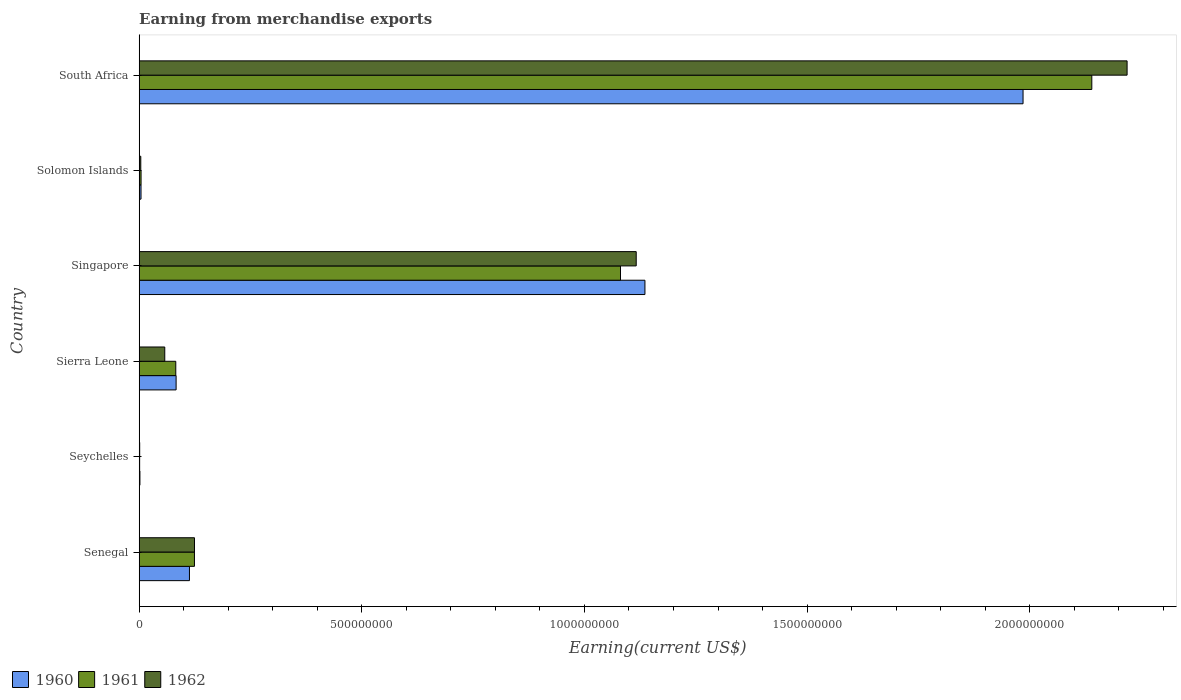How many different coloured bars are there?
Your answer should be compact. 3. How many bars are there on the 4th tick from the top?
Offer a very short reply. 3. How many bars are there on the 6th tick from the bottom?
Your answer should be compact. 3. What is the label of the 3rd group of bars from the top?
Ensure brevity in your answer.  Singapore. What is the amount earned from merchandise exports in 1960 in Sierra Leone?
Give a very brief answer. 8.30e+07. Across all countries, what is the maximum amount earned from merchandise exports in 1962?
Provide a succinct answer. 2.22e+09. Across all countries, what is the minimum amount earned from merchandise exports in 1961?
Provide a succinct answer. 1.06e+06. In which country was the amount earned from merchandise exports in 1961 maximum?
Make the answer very short. South Africa. In which country was the amount earned from merchandise exports in 1962 minimum?
Your answer should be compact. Seychelles. What is the total amount earned from merchandise exports in 1961 in the graph?
Your response must be concise. 3.43e+09. What is the difference between the amount earned from merchandise exports in 1962 in Solomon Islands and that in South Africa?
Make the answer very short. -2.21e+09. What is the difference between the amount earned from merchandise exports in 1960 in Sierra Leone and the amount earned from merchandise exports in 1961 in South Africa?
Your answer should be very brief. -2.06e+09. What is the average amount earned from merchandise exports in 1962 per country?
Provide a short and direct response. 5.87e+08. What is the difference between the amount earned from merchandise exports in 1961 and amount earned from merchandise exports in 1960 in Singapore?
Ensure brevity in your answer.  -5.49e+07. What is the ratio of the amount earned from merchandise exports in 1962 in Solomon Islands to that in South Africa?
Offer a very short reply. 0. What is the difference between the highest and the second highest amount earned from merchandise exports in 1961?
Offer a very short reply. 1.06e+09. What is the difference between the highest and the lowest amount earned from merchandise exports in 1962?
Offer a very short reply. 2.22e+09. Is the sum of the amount earned from merchandise exports in 1962 in Singapore and South Africa greater than the maximum amount earned from merchandise exports in 1960 across all countries?
Ensure brevity in your answer.  Yes. What does the 2nd bar from the top in Singapore represents?
Your answer should be compact. 1961. Is it the case that in every country, the sum of the amount earned from merchandise exports in 1960 and amount earned from merchandise exports in 1962 is greater than the amount earned from merchandise exports in 1961?
Offer a very short reply. Yes. How many bars are there?
Your answer should be very brief. 18. Are all the bars in the graph horizontal?
Ensure brevity in your answer.  Yes. How many countries are there in the graph?
Your response must be concise. 6. What is the difference between two consecutive major ticks on the X-axis?
Keep it short and to the point. 5.00e+08. Does the graph contain any zero values?
Offer a terse response. No. How many legend labels are there?
Ensure brevity in your answer.  3. What is the title of the graph?
Give a very brief answer. Earning from merchandise exports. Does "2012" appear as one of the legend labels in the graph?
Provide a succinct answer. No. What is the label or title of the X-axis?
Keep it short and to the point. Earning(current US$). What is the Earning(current US$) of 1960 in Senegal?
Make the answer very short. 1.13e+08. What is the Earning(current US$) in 1961 in Senegal?
Make the answer very short. 1.24e+08. What is the Earning(current US$) in 1962 in Senegal?
Offer a terse response. 1.24e+08. What is the Earning(current US$) in 1960 in Seychelles?
Provide a succinct answer. 1.70e+06. What is the Earning(current US$) of 1961 in Seychelles?
Provide a succinct answer. 1.06e+06. What is the Earning(current US$) of 1962 in Seychelles?
Make the answer very short. 1.17e+06. What is the Earning(current US$) of 1960 in Sierra Leone?
Offer a terse response. 8.30e+07. What is the Earning(current US$) in 1961 in Sierra Leone?
Your answer should be compact. 8.22e+07. What is the Earning(current US$) in 1962 in Sierra Leone?
Keep it short and to the point. 5.75e+07. What is the Earning(current US$) in 1960 in Singapore?
Your response must be concise. 1.14e+09. What is the Earning(current US$) of 1961 in Singapore?
Provide a short and direct response. 1.08e+09. What is the Earning(current US$) of 1962 in Singapore?
Make the answer very short. 1.12e+09. What is the Earning(current US$) in 1960 in Solomon Islands?
Provide a succinct answer. 4.16e+06. What is the Earning(current US$) in 1961 in Solomon Islands?
Make the answer very short. 4.29e+06. What is the Earning(current US$) in 1962 in Solomon Islands?
Your response must be concise. 3.64e+06. What is the Earning(current US$) in 1960 in South Africa?
Provide a short and direct response. 1.98e+09. What is the Earning(current US$) in 1961 in South Africa?
Your answer should be very brief. 2.14e+09. What is the Earning(current US$) of 1962 in South Africa?
Your response must be concise. 2.22e+09. Across all countries, what is the maximum Earning(current US$) in 1960?
Your answer should be very brief. 1.98e+09. Across all countries, what is the maximum Earning(current US$) of 1961?
Your response must be concise. 2.14e+09. Across all countries, what is the maximum Earning(current US$) of 1962?
Ensure brevity in your answer.  2.22e+09. Across all countries, what is the minimum Earning(current US$) of 1960?
Keep it short and to the point. 1.70e+06. Across all countries, what is the minimum Earning(current US$) in 1961?
Give a very brief answer. 1.06e+06. Across all countries, what is the minimum Earning(current US$) of 1962?
Offer a terse response. 1.17e+06. What is the total Earning(current US$) of 1960 in the graph?
Offer a very short reply. 3.32e+09. What is the total Earning(current US$) in 1961 in the graph?
Make the answer very short. 3.43e+09. What is the total Earning(current US$) in 1962 in the graph?
Provide a succinct answer. 3.52e+09. What is the difference between the Earning(current US$) of 1960 in Senegal and that in Seychelles?
Provide a succinct answer. 1.11e+08. What is the difference between the Earning(current US$) in 1961 in Senegal and that in Seychelles?
Offer a very short reply. 1.23e+08. What is the difference between the Earning(current US$) in 1962 in Senegal and that in Seychelles?
Offer a very short reply. 1.23e+08. What is the difference between the Earning(current US$) in 1960 in Senegal and that in Sierra Leone?
Your answer should be compact. 3.00e+07. What is the difference between the Earning(current US$) in 1961 in Senegal and that in Sierra Leone?
Ensure brevity in your answer.  4.19e+07. What is the difference between the Earning(current US$) of 1962 in Senegal and that in Sierra Leone?
Your answer should be compact. 6.68e+07. What is the difference between the Earning(current US$) of 1960 in Senegal and that in Singapore?
Offer a terse response. -1.02e+09. What is the difference between the Earning(current US$) of 1961 in Senegal and that in Singapore?
Your answer should be very brief. -9.57e+08. What is the difference between the Earning(current US$) in 1962 in Senegal and that in Singapore?
Your response must be concise. -9.92e+08. What is the difference between the Earning(current US$) in 1960 in Senegal and that in Solomon Islands?
Keep it short and to the point. 1.09e+08. What is the difference between the Earning(current US$) of 1961 in Senegal and that in Solomon Islands?
Ensure brevity in your answer.  1.20e+08. What is the difference between the Earning(current US$) in 1962 in Senegal and that in Solomon Islands?
Make the answer very short. 1.21e+08. What is the difference between the Earning(current US$) in 1960 in Senegal and that in South Africa?
Your response must be concise. -1.87e+09. What is the difference between the Earning(current US$) of 1961 in Senegal and that in South Africa?
Your response must be concise. -2.02e+09. What is the difference between the Earning(current US$) in 1962 in Senegal and that in South Africa?
Make the answer very short. -2.09e+09. What is the difference between the Earning(current US$) of 1960 in Seychelles and that in Sierra Leone?
Provide a succinct answer. -8.13e+07. What is the difference between the Earning(current US$) of 1961 in Seychelles and that in Sierra Leone?
Offer a terse response. -8.12e+07. What is the difference between the Earning(current US$) of 1962 in Seychelles and that in Sierra Leone?
Offer a very short reply. -5.63e+07. What is the difference between the Earning(current US$) of 1960 in Seychelles and that in Singapore?
Ensure brevity in your answer.  -1.13e+09. What is the difference between the Earning(current US$) in 1961 in Seychelles and that in Singapore?
Your response must be concise. -1.08e+09. What is the difference between the Earning(current US$) of 1962 in Seychelles and that in Singapore?
Provide a short and direct response. -1.12e+09. What is the difference between the Earning(current US$) of 1960 in Seychelles and that in Solomon Islands?
Your answer should be very brief. -2.46e+06. What is the difference between the Earning(current US$) in 1961 in Seychelles and that in Solomon Islands?
Make the answer very short. -3.23e+06. What is the difference between the Earning(current US$) of 1962 in Seychelles and that in Solomon Islands?
Provide a succinct answer. -2.48e+06. What is the difference between the Earning(current US$) in 1960 in Seychelles and that in South Africa?
Offer a terse response. -1.98e+09. What is the difference between the Earning(current US$) in 1961 in Seychelles and that in South Africa?
Offer a terse response. -2.14e+09. What is the difference between the Earning(current US$) in 1962 in Seychelles and that in South Africa?
Ensure brevity in your answer.  -2.22e+09. What is the difference between the Earning(current US$) of 1960 in Sierra Leone and that in Singapore?
Keep it short and to the point. -1.05e+09. What is the difference between the Earning(current US$) of 1961 in Sierra Leone and that in Singapore?
Your answer should be very brief. -9.99e+08. What is the difference between the Earning(current US$) in 1962 in Sierra Leone and that in Singapore?
Ensure brevity in your answer.  -1.06e+09. What is the difference between the Earning(current US$) of 1960 in Sierra Leone and that in Solomon Islands?
Make the answer very short. 7.88e+07. What is the difference between the Earning(current US$) of 1961 in Sierra Leone and that in Solomon Islands?
Your response must be concise. 7.80e+07. What is the difference between the Earning(current US$) of 1962 in Sierra Leone and that in Solomon Islands?
Provide a short and direct response. 5.38e+07. What is the difference between the Earning(current US$) of 1960 in Sierra Leone and that in South Africa?
Your answer should be compact. -1.90e+09. What is the difference between the Earning(current US$) of 1961 in Sierra Leone and that in South Africa?
Offer a very short reply. -2.06e+09. What is the difference between the Earning(current US$) of 1962 in Sierra Leone and that in South Africa?
Provide a succinct answer. -2.16e+09. What is the difference between the Earning(current US$) of 1960 in Singapore and that in Solomon Islands?
Offer a terse response. 1.13e+09. What is the difference between the Earning(current US$) of 1961 in Singapore and that in Solomon Islands?
Your answer should be compact. 1.08e+09. What is the difference between the Earning(current US$) in 1962 in Singapore and that in Solomon Islands?
Provide a succinct answer. 1.11e+09. What is the difference between the Earning(current US$) of 1960 in Singapore and that in South Africa?
Give a very brief answer. -8.49e+08. What is the difference between the Earning(current US$) of 1961 in Singapore and that in South Africa?
Offer a very short reply. -1.06e+09. What is the difference between the Earning(current US$) of 1962 in Singapore and that in South Africa?
Make the answer very short. -1.10e+09. What is the difference between the Earning(current US$) in 1960 in Solomon Islands and that in South Africa?
Offer a terse response. -1.98e+09. What is the difference between the Earning(current US$) in 1961 in Solomon Islands and that in South Africa?
Offer a very short reply. -2.14e+09. What is the difference between the Earning(current US$) of 1962 in Solomon Islands and that in South Africa?
Offer a terse response. -2.21e+09. What is the difference between the Earning(current US$) in 1960 in Senegal and the Earning(current US$) in 1961 in Seychelles?
Offer a terse response. 1.12e+08. What is the difference between the Earning(current US$) of 1960 in Senegal and the Earning(current US$) of 1962 in Seychelles?
Make the answer very short. 1.12e+08. What is the difference between the Earning(current US$) of 1961 in Senegal and the Earning(current US$) of 1962 in Seychelles?
Ensure brevity in your answer.  1.23e+08. What is the difference between the Earning(current US$) in 1960 in Senegal and the Earning(current US$) in 1961 in Sierra Leone?
Offer a very short reply. 3.07e+07. What is the difference between the Earning(current US$) of 1960 in Senegal and the Earning(current US$) of 1962 in Sierra Leone?
Keep it short and to the point. 5.55e+07. What is the difference between the Earning(current US$) in 1961 in Senegal and the Earning(current US$) in 1962 in Sierra Leone?
Offer a very short reply. 6.67e+07. What is the difference between the Earning(current US$) in 1960 in Senegal and the Earning(current US$) in 1961 in Singapore?
Offer a terse response. -9.68e+08. What is the difference between the Earning(current US$) of 1960 in Senegal and the Earning(current US$) of 1962 in Singapore?
Ensure brevity in your answer.  -1.00e+09. What is the difference between the Earning(current US$) in 1961 in Senegal and the Earning(current US$) in 1962 in Singapore?
Your response must be concise. -9.92e+08. What is the difference between the Earning(current US$) in 1960 in Senegal and the Earning(current US$) in 1961 in Solomon Islands?
Offer a very short reply. 1.09e+08. What is the difference between the Earning(current US$) of 1960 in Senegal and the Earning(current US$) of 1962 in Solomon Islands?
Make the answer very short. 1.09e+08. What is the difference between the Earning(current US$) of 1961 in Senegal and the Earning(current US$) of 1962 in Solomon Islands?
Provide a succinct answer. 1.21e+08. What is the difference between the Earning(current US$) in 1960 in Senegal and the Earning(current US$) in 1961 in South Africa?
Your answer should be very brief. -2.03e+09. What is the difference between the Earning(current US$) of 1960 in Senegal and the Earning(current US$) of 1962 in South Africa?
Keep it short and to the point. -2.11e+09. What is the difference between the Earning(current US$) of 1961 in Senegal and the Earning(current US$) of 1962 in South Africa?
Make the answer very short. -2.09e+09. What is the difference between the Earning(current US$) in 1960 in Seychelles and the Earning(current US$) in 1961 in Sierra Leone?
Offer a terse response. -8.05e+07. What is the difference between the Earning(current US$) in 1960 in Seychelles and the Earning(current US$) in 1962 in Sierra Leone?
Offer a very short reply. -5.58e+07. What is the difference between the Earning(current US$) in 1961 in Seychelles and the Earning(current US$) in 1962 in Sierra Leone?
Give a very brief answer. -5.64e+07. What is the difference between the Earning(current US$) of 1960 in Seychelles and the Earning(current US$) of 1961 in Singapore?
Ensure brevity in your answer.  -1.08e+09. What is the difference between the Earning(current US$) of 1960 in Seychelles and the Earning(current US$) of 1962 in Singapore?
Your answer should be compact. -1.11e+09. What is the difference between the Earning(current US$) in 1961 in Seychelles and the Earning(current US$) in 1962 in Singapore?
Your response must be concise. -1.12e+09. What is the difference between the Earning(current US$) of 1960 in Seychelles and the Earning(current US$) of 1961 in Solomon Islands?
Provide a short and direct response. -2.59e+06. What is the difference between the Earning(current US$) of 1960 in Seychelles and the Earning(current US$) of 1962 in Solomon Islands?
Give a very brief answer. -1.94e+06. What is the difference between the Earning(current US$) in 1961 in Seychelles and the Earning(current US$) in 1962 in Solomon Islands?
Your response must be concise. -2.58e+06. What is the difference between the Earning(current US$) of 1960 in Seychelles and the Earning(current US$) of 1961 in South Africa?
Provide a succinct answer. -2.14e+09. What is the difference between the Earning(current US$) of 1960 in Seychelles and the Earning(current US$) of 1962 in South Africa?
Your response must be concise. -2.22e+09. What is the difference between the Earning(current US$) in 1961 in Seychelles and the Earning(current US$) in 1962 in South Africa?
Keep it short and to the point. -2.22e+09. What is the difference between the Earning(current US$) of 1960 in Sierra Leone and the Earning(current US$) of 1961 in Singapore?
Ensure brevity in your answer.  -9.98e+08. What is the difference between the Earning(current US$) of 1960 in Sierra Leone and the Earning(current US$) of 1962 in Singapore?
Offer a very short reply. -1.03e+09. What is the difference between the Earning(current US$) in 1961 in Sierra Leone and the Earning(current US$) in 1962 in Singapore?
Keep it short and to the point. -1.03e+09. What is the difference between the Earning(current US$) of 1960 in Sierra Leone and the Earning(current US$) of 1961 in Solomon Islands?
Offer a very short reply. 7.87e+07. What is the difference between the Earning(current US$) of 1960 in Sierra Leone and the Earning(current US$) of 1962 in Solomon Islands?
Make the answer very short. 7.93e+07. What is the difference between the Earning(current US$) in 1961 in Sierra Leone and the Earning(current US$) in 1962 in Solomon Islands?
Your answer should be very brief. 7.86e+07. What is the difference between the Earning(current US$) in 1960 in Sierra Leone and the Earning(current US$) in 1961 in South Africa?
Your answer should be very brief. -2.06e+09. What is the difference between the Earning(current US$) of 1960 in Sierra Leone and the Earning(current US$) of 1962 in South Africa?
Provide a short and direct response. -2.14e+09. What is the difference between the Earning(current US$) of 1961 in Sierra Leone and the Earning(current US$) of 1962 in South Africa?
Keep it short and to the point. -2.14e+09. What is the difference between the Earning(current US$) in 1960 in Singapore and the Earning(current US$) in 1961 in Solomon Islands?
Ensure brevity in your answer.  1.13e+09. What is the difference between the Earning(current US$) in 1960 in Singapore and the Earning(current US$) in 1962 in Solomon Islands?
Offer a very short reply. 1.13e+09. What is the difference between the Earning(current US$) of 1961 in Singapore and the Earning(current US$) of 1962 in Solomon Islands?
Ensure brevity in your answer.  1.08e+09. What is the difference between the Earning(current US$) in 1960 in Singapore and the Earning(current US$) in 1961 in South Africa?
Offer a terse response. -1.00e+09. What is the difference between the Earning(current US$) of 1960 in Singapore and the Earning(current US$) of 1962 in South Africa?
Provide a short and direct response. -1.08e+09. What is the difference between the Earning(current US$) in 1961 in Singapore and the Earning(current US$) in 1962 in South Africa?
Make the answer very short. -1.14e+09. What is the difference between the Earning(current US$) in 1960 in Solomon Islands and the Earning(current US$) in 1961 in South Africa?
Ensure brevity in your answer.  -2.14e+09. What is the difference between the Earning(current US$) of 1960 in Solomon Islands and the Earning(current US$) of 1962 in South Africa?
Keep it short and to the point. -2.21e+09. What is the difference between the Earning(current US$) of 1961 in Solomon Islands and the Earning(current US$) of 1962 in South Africa?
Ensure brevity in your answer.  -2.21e+09. What is the average Earning(current US$) of 1960 per country?
Make the answer very short. 5.54e+08. What is the average Earning(current US$) of 1961 per country?
Provide a succinct answer. 5.72e+08. What is the average Earning(current US$) in 1962 per country?
Your answer should be compact. 5.87e+08. What is the difference between the Earning(current US$) in 1960 and Earning(current US$) in 1961 in Senegal?
Give a very brief answer. -1.12e+07. What is the difference between the Earning(current US$) of 1960 and Earning(current US$) of 1962 in Senegal?
Give a very brief answer. -1.13e+07. What is the difference between the Earning(current US$) in 1961 and Earning(current US$) in 1962 in Senegal?
Your answer should be compact. -8.10e+04. What is the difference between the Earning(current US$) in 1960 and Earning(current US$) in 1961 in Seychelles?
Your answer should be compact. 6.42e+05. What is the difference between the Earning(current US$) in 1960 and Earning(current US$) in 1962 in Seychelles?
Keep it short and to the point. 5.32e+05. What is the difference between the Earning(current US$) in 1961 and Earning(current US$) in 1962 in Seychelles?
Make the answer very short. -1.09e+05. What is the difference between the Earning(current US$) in 1960 and Earning(current US$) in 1961 in Sierra Leone?
Make the answer very short. 7.27e+05. What is the difference between the Earning(current US$) in 1960 and Earning(current US$) in 1962 in Sierra Leone?
Give a very brief answer. 2.55e+07. What is the difference between the Earning(current US$) of 1961 and Earning(current US$) of 1962 in Sierra Leone?
Offer a terse response. 2.48e+07. What is the difference between the Earning(current US$) in 1960 and Earning(current US$) in 1961 in Singapore?
Provide a succinct answer. 5.49e+07. What is the difference between the Earning(current US$) of 1960 and Earning(current US$) of 1962 in Singapore?
Offer a terse response. 1.96e+07. What is the difference between the Earning(current US$) in 1961 and Earning(current US$) in 1962 in Singapore?
Give a very brief answer. -3.53e+07. What is the difference between the Earning(current US$) in 1960 and Earning(current US$) in 1961 in Solomon Islands?
Ensure brevity in your answer.  -1.24e+05. What is the difference between the Earning(current US$) in 1960 and Earning(current US$) in 1962 in Solomon Islands?
Your answer should be very brief. 5.17e+05. What is the difference between the Earning(current US$) of 1961 and Earning(current US$) of 1962 in Solomon Islands?
Give a very brief answer. 6.42e+05. What is the difference between the Earning(current US$) of 1960 and Earning(current US$) of 1961 in South Africa?
Offer a terse response. -1.54e+08. What is the difference between the Earning(current US$) of 1960 and Earning(current US$) of 1962 in South Africa?
Offer a terse response. -2.34e+08. What is the difference between the Earning(current US$) of 1961 and Earning(current US$) of 1962 in South Africa?
Offer a very short reply. -7.92e+07. What is the ratio of the Earning(current US$) in 1960 in Senegal to that in Seychelles?
Ensure brevity in your answer.  66.44. What is the ratio of the Earning(current US$) of 1961 in Senegal to that in Seychelles?
Make the answer very short. 117.31. What is the ratio of the Earning(current US$) in 1962 in Senegal to that in Seychelles?
Give a very brief answer. 106.41. What is the ratio of the Earning(current US$) in 1960 in Senegal to that in Sierra Leone?
Give a very brief answer. 1.36. What is the ratio of the Earning(current US$) in 1961 in Senegal to that in Sierra Leone?
Provide a short and direct response. 1.51. What is the ratio of the Earning(current US$) in 1962 in Senegal to that in Sierra Leone?
Ensure brevity in your answer.  2.16. What is the ratio of the Earning(current US$) in 1960 in Senegal to that in Singapore?
Ensure brevity in your answer.  0.1. What is the ratio of the Earning(current US$) of 1961 in Senegal to that in Singapore?
Make the answer very short. 0.11. What is the ratio of the Earning(current US$) of 1962 in Senegal to that in Singapore?
Your answer should be compact. 0.11. What is the ratio of the Earning(current US$) in 1960 in Senegal to that in Solomon Islands?
Keep it short and to the point. 27.14. What is the ratio of the Earning(current US$) in 1961 in Senegal to that in Solomon Islands?
Ensure brevity in your answer.  28.98. What is the ratio of the Earning(current US$) of 1962 in Senegal to that in Solomon Islands?
Provide a short and direct response. 34.1. What is the ratio of the Earning(current US$) of 1960 in Senegal to that in South Africa?
Your answer should be very brief. 0.06. What is the ratio of the Earning(current US$) of 1961 in Senegal to that in South Africa?
Keep it short and to the point. 0.06. What is the ratio of the Earning(current US$) of 1962 in Senegal to that in South Africa?
Offer a very short reply. 0.06. What is the ratio of the Earning(current US$) in 1960 in Seychelles to that in Sierra Leone?
Give a very brief answer. 0.02. What is the ratio of the Earning(current US$) of 1961 in Seychelles to that in Sierra Leone?
Your response must be concise. 0.01. What is the ratio of the Earning(current US$) in 1962 in Seychelles to that in Sierra Leone?
Provide a short and direct response. 0.02. What is the ratio of the Earning(current US$) of 1960 in Seychelles to that in Singapore?
Your answer should be compact. 0. What is the ratio of the Earning(current US$) in 1961 in Seychelles to that in Singapore?
Keep it short and to the point. 0. What is the ratio of the Earning(current US$) of 1962 in Seychelles to that in Singapore?
Provide a short and direct response. 0. What is the ratio of the Earning(current US$) in 1960 in Seychelles to that in Solomon Islands?
Keep it short and to the point. 0.41. What is the ratio of the Earning(current US$) of 1961 in Seychelles to that in Solomon Islands?
Make the answer very short. 0.25. What is the ratio of the Earning(current US$) in 1962 in Seychelles to that in Solomon Islands?
Provide a succinct answer. 0.32. What is the ratio of the Earning(current US$) in 1960 in Seychelles to that in South Africa?
Make the answer very short. 0. What is the ratio of the Earning(current US$) in 1961 in Seychelles to that in South Africa?
Your answer should be very brief. 0. What is the ratio of the Earning(current US$) of 1962 in Seychelles to that in South Africa?
Provide a succinct answer. 0. What is the ratio of the Earning(current US$) of 1960 in Sierra Leone to that in Singapore?
Your response must be concise. 0.07. What is the ratio of the Earning(current US$) of 1961 in Sierra Leone to that in Singapore?
Make the answer very short. 0.08. What is the ratio of the Earning(current US$) of 1962 in Sierra Leone to that in Singapore?
Ensure brevity in your answer.  0.05. What is the ratio of the Earning(current US$) of 1960 in Sierra Leone to that in Solomon Islands?
Provide a succinct answer. 19.94. What is the ratio of the Earning(current US$) in 1961 in Sierra Leone to that in Solomon Islands?
Offer a terse response. 19.19. What is the ratio of the Earning(current US$) of 1962 in Sierra Leone to that in Solomon Islands?
Offer a very short reply. 15.78. What is the ratio of the Earning(current US$) in 1960 in Sierra Leone to that in South Africa?
Provide a short and direct response. 0.04. What is the ratio of the Earning(current US$) in 1961 in Sierra Leone to that in South Africa?
Give a very brief answer. 0.04. What is the ratio of the Earning(current US$) of 1962 in Sierra Leone to that in South Africa?
Your response must be concise. 0.03. What is the ratio of the Earning(current US$) of 1960 in Singapore to that in Solomon Islands?
Keep it short and to the point. 272.98. What is the ratio of the Earning(current US$) of 1961 in Singapore to that in Solomon Islands?
Offer a terse response. 252.25. What is the ratio of the Earning(current US$) in 1962 in Singapore to that in Solomon Islands?
Offer a terse response. 306.37. What is the ratio of the Earning(current US$) in 1960 in Singapore to that in South Africa?
Your answer should be very brief. 0.57. What is the ratio of the Earning(current US$) of 1961 in Singapore to that in South Africa?
Your answer should be very brief. 0.51. What is the ratio of the Earning(current US$) in 1962 in Singapore to that in South Africa?
Your answer should be very brief. 0.5. What is the ratio of the Earning(current US$) of 1960 in Solomon Islands to that in South Africa?
Provide a short and direct response. 0. What is the ratio of the Earning(current US$) of 1961 in Solomon Islands to that in South Africa?
Ensure brevity in your answer.  0. What is the ratio of the Earning(current US$) of 1962 in Solomon Islands to that in South Africa?
Offer a terse response. 0. What is the difference between the highest and the second highest Earning(current US$) in 1960?
Your response must be concise. 8.49e+08. What is the difference between the highest and the second highest Earning(current US$) of 1961?
Ensure brevity in your answer.  1.06e+09. What is the difference between the highest and the second highest Earning(current US$) in 1962?
Ensure brevity in your answer.  1.10e+09. What is the difference between the highest and the lowest Earning(current US$) of 1960?
Offer a terse response. 1.98e+09. What is the difference between the highest and the lowest Earning(current US$) in 1961?
Offer a very short reply. 2.14e+09. What is the difference between the highest and the lowest Earning(current US$) of 1962?
Keep it short and to the point. 2.22e+09. 